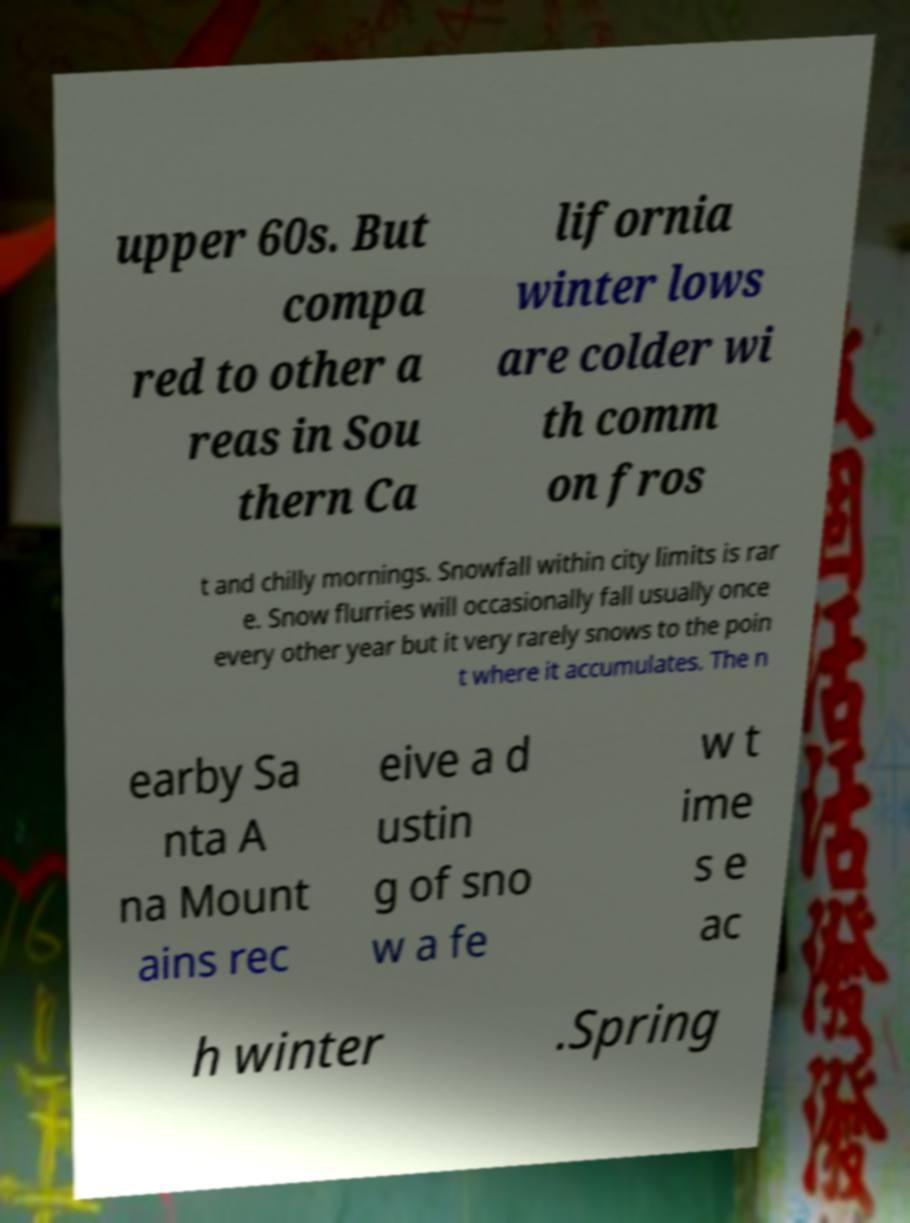For documentation purposes, I need the text within this image transcribed. Could you provide that? upper 60s. But compa red to other a reas in Sou thern Ca lifornia winter lows are colder wi th comm on fros t and chilly mornings. Snowfall within city limits is rar e. Snow flurries will occasionally fall usually once every other year but it very rarely snows to the poin t where it accumulates. The n earby Sa nta A na Mount ains rec eive a d ustin g of sno w a fe w t ime s e ac h winter .Spring 